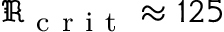<formula> <loc_0><loc_0><loc_500><loc_500>\Re _ { c r i t } \approx 1 2 5</formula> 